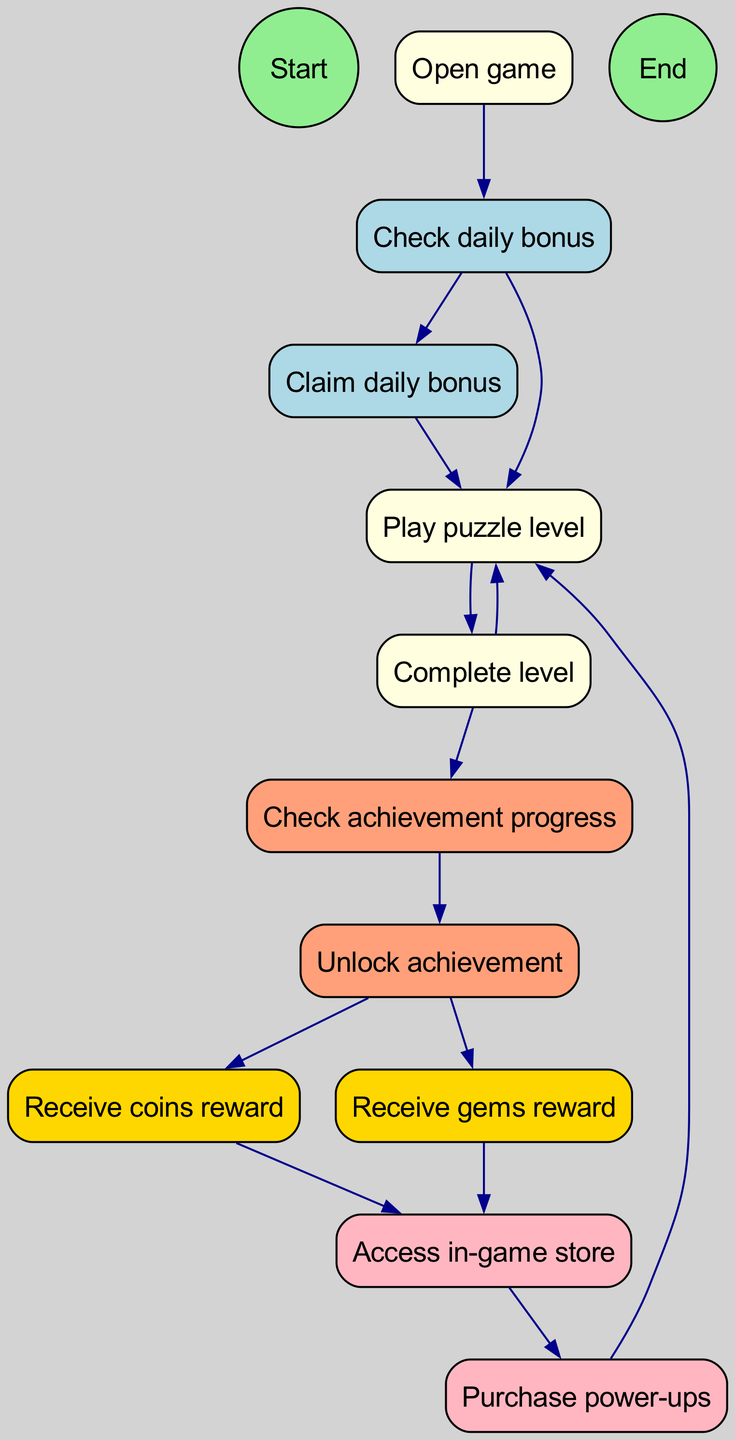What is the starting point of the activity diagram? The starting point is labeled as "Start" which indicates where the process begins in the flow of the activity diagram.
Answer: Start How many nodes are present in the diagram? By counting all unique elements in the nodes list provided, we find that there are 12 nodes listed in total.
Answer: 12 What comes after "Check daily bonus" in the diagram? From the connections in the diagram, after "Check daily bonus," the next steps can be either "Claim daily bonus" or "Play puzzle level." Since both branches emanate from this node, they are the results of checking the daily bonus.
Answer: Claim daily bonus, Play puzzle level What are the rewards received after unlocking an achievement? The diagram specifies that after "Unlock achievement," the rewards received are "Receive coins reward" and "Receive gems reward."
Answer: Coins reward, Gems reward How many edges connect the nodes in the diagram? To find the total edges, we count each directional connection listed in the edges property which results in 12 edges.
Answer: 12 What is the final step indicated by the diagram? The last step in this activity diagram is represented by the node labeled "End," which signifies the conclusion of the process flow after the actions have been completed.
Answer: End What actions can lead to accessing the in-game store? According to the diagram, two paths lead to "Access in-game store": one from "Receive coins reward" and another from "Receive gems reward," indicating that both types of rewards allow the player to access the store.
Answer: Receive coins reward, Receive gems reward What is the relationship between "Complete level" and "Play puzzle level"? The diagram indicates that after "Complete level," the player returns to "Play puzzle level," showing a cyclical relationship where completing a level leads back to playing another level.
Answer: Play puzzle level What must be done to claim a daily bonus? Based on the diagram, after "Check daily bonus," the action "Claim daily bonus" must be completed to receive the daily bonus.
Answer: Claim daily bonus 